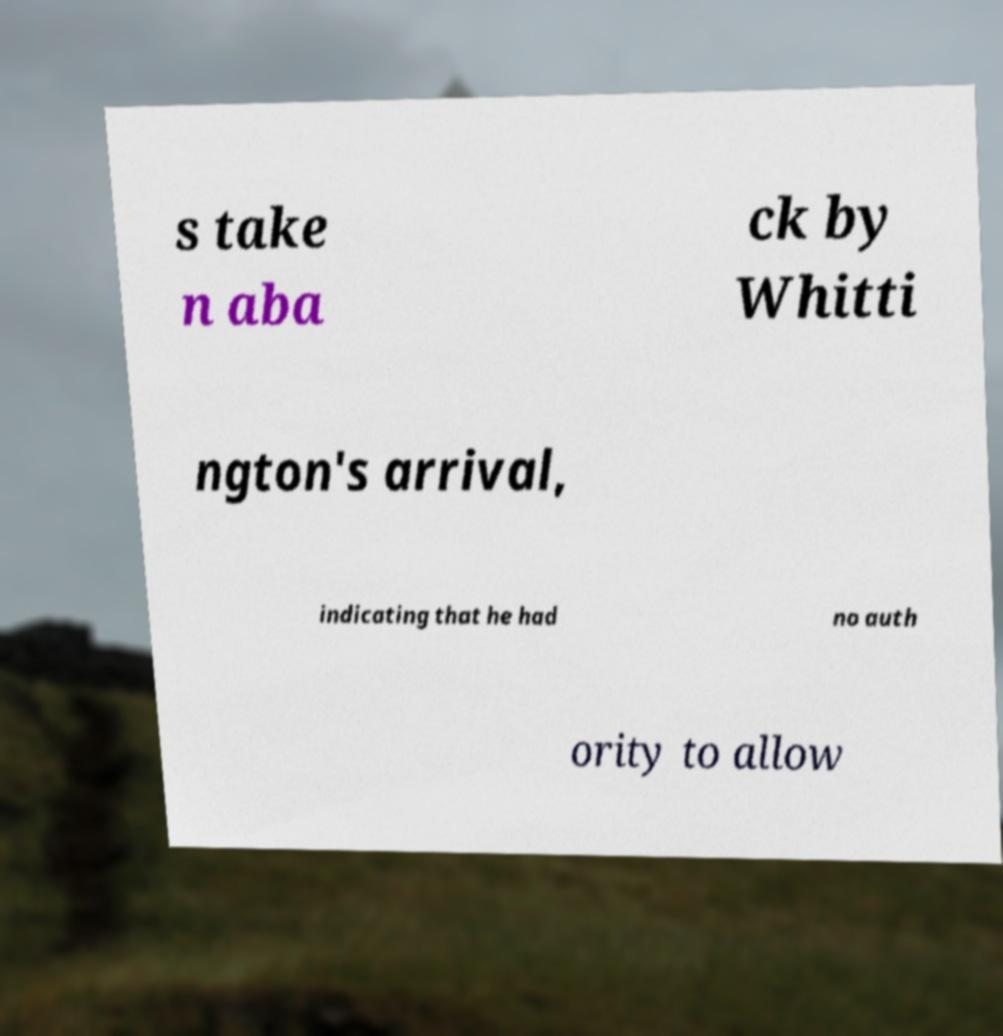I need the written content from this picture converted into text. Can you do that? s take n aba ck by Whitti ngton's arrival, indicating that he had no auth ority to allow 